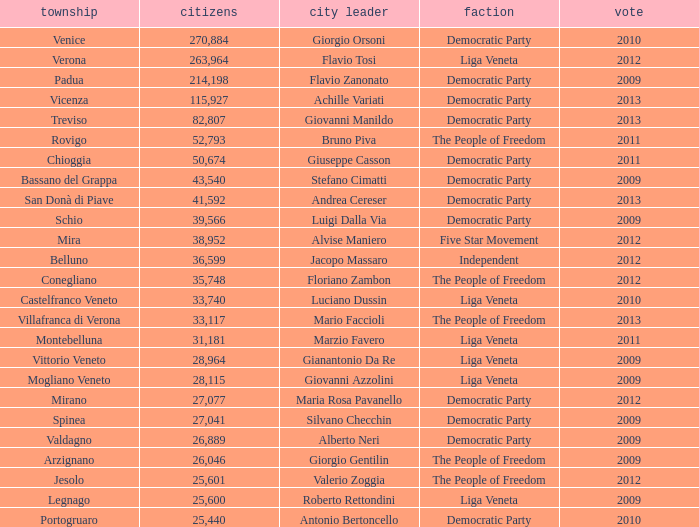How many elections had more than 36,599 inhabitants when Mayor was giovanni manildo? 1.0. 